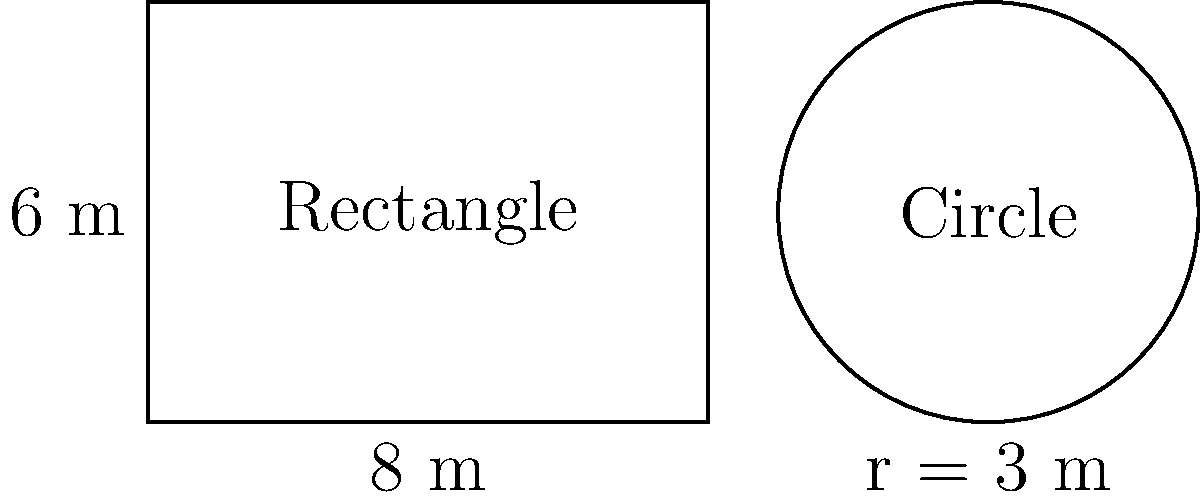As a party planner, you're organizing a house party and need to decide between two table shapes for optimal seating. You have the option of a rectangular table measuring 8 m by 6 m or a circular table with a radius of 3 m. Assuming each guest requires 0.75 m² of table space, which table shape would accommodate more guests? Calculate the difference in guest capacity between the two table shapes. Let's approach this step-by-step:

1. Calculate the area of the rectangular table:
   $$A_r = l \times w = 8 \text{ m} \times 6 \text{ m} = 48 \text{ m}^2$$

2. Calculate the area of the circular table:
   $$A_c = \pi r^2 = \pi \times (3 \text{ m})^2 = 28.27 \text{ m}^2$$

3. Calculate the number of guests for the rectangular table:
   $$N_r = \frac{A_r}{0.75 \text{ m}^2} = \frac{48 \text{ m}^2}{0.75 \text{ m}^2} = 64 \text{ guests}$$

4. Calculate the number of guests for the circular table:
   $$N_c = \frac{A_c}{0.75 \text{ m}^2} = \frac{28.27 \text{ m}^2}{0.75 \text{ m}^2} = 37.69 \approx 37 \text{ guests}$$

5. Calculate the difference in guest capacity:
   $$\text{Difference} = N_r - N_c = 64 - 37 = 27 \text{ guests}$$

Therefore, the rectangular table can accommodate 27 more guests than the circular table.
Answer: Rectangular table; 27 more guests 